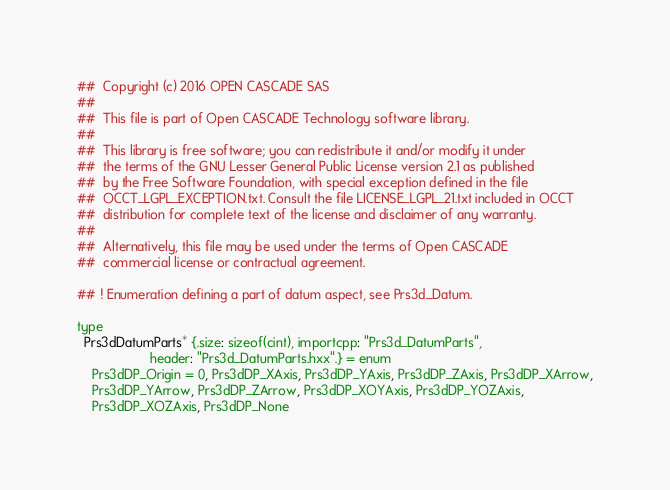Convert code to text. <code><loc_0><loc_0><loc_500><loc_500><_Nim_>##  Copyright (c) 2016 OPEN CASCADE SAS
##
##  This file is part of Open CASCADE Technology software library.
##
##  This library is free software; you can redistribute it and/or modify it under
##  the terms of the GNU Lesser General Public License version 2.1 as published
##  by the Free Software Foundation, with special exception defined in the file
##  OCCT_LGPL_EXCEPTION.txt. Consult the file LICENSE_LGPL_21.txt included in OCCT
##  distribution for complete text of the license and disclaimer of any warranty.
##
##  Alternatively, this file may be used under the terms of Open CASCADE
##  commercial license or contractual agreement.

## ! Enumeration defining a part of datum aspect, see Prs3d_Datum.

type
  Prs3dDatumParts* {.size: sizeof(cint), importcpp: "Prs3d_DatumParts",
                    header: "Prs3d_DatumParts.hxx".} = enum
    Prs3dDP_Origin = 0, Prs3dDP_XAxis, Prs3dDP_YAxis, Prs3dDP_ZAxis, Prs3dDP_XArrow,
    Prs3dDP_YArrow, Prs3dDP_ZArrow, Prs3dDP_XOYAxis, Prs3dDP_YOZAxis,
    Prs3dDP_XOZAxis, Prs3dDP_None



























</code> 